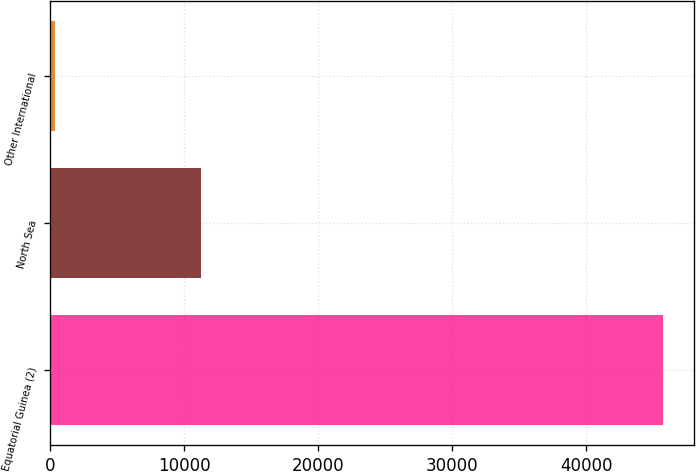Convert chart to OTSL. <chart><loc_0><loc_0><loc_500><loc_500><bar_chart><fcel>Equatorial Guinea (2)<fcel>North Sea<fcel>Other International<nl><fcel>45755<fcel>11286<fcel>387<nl></chart> 